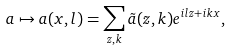Convert formula to latex. <formula><loc_0><loc_0><loc_500><loc_500>a \mapsto a ( x , l ) = \sum _ { z , k } \tilde { a } ( z , k ) e ^ { i l z + i k x } ,</formula> 